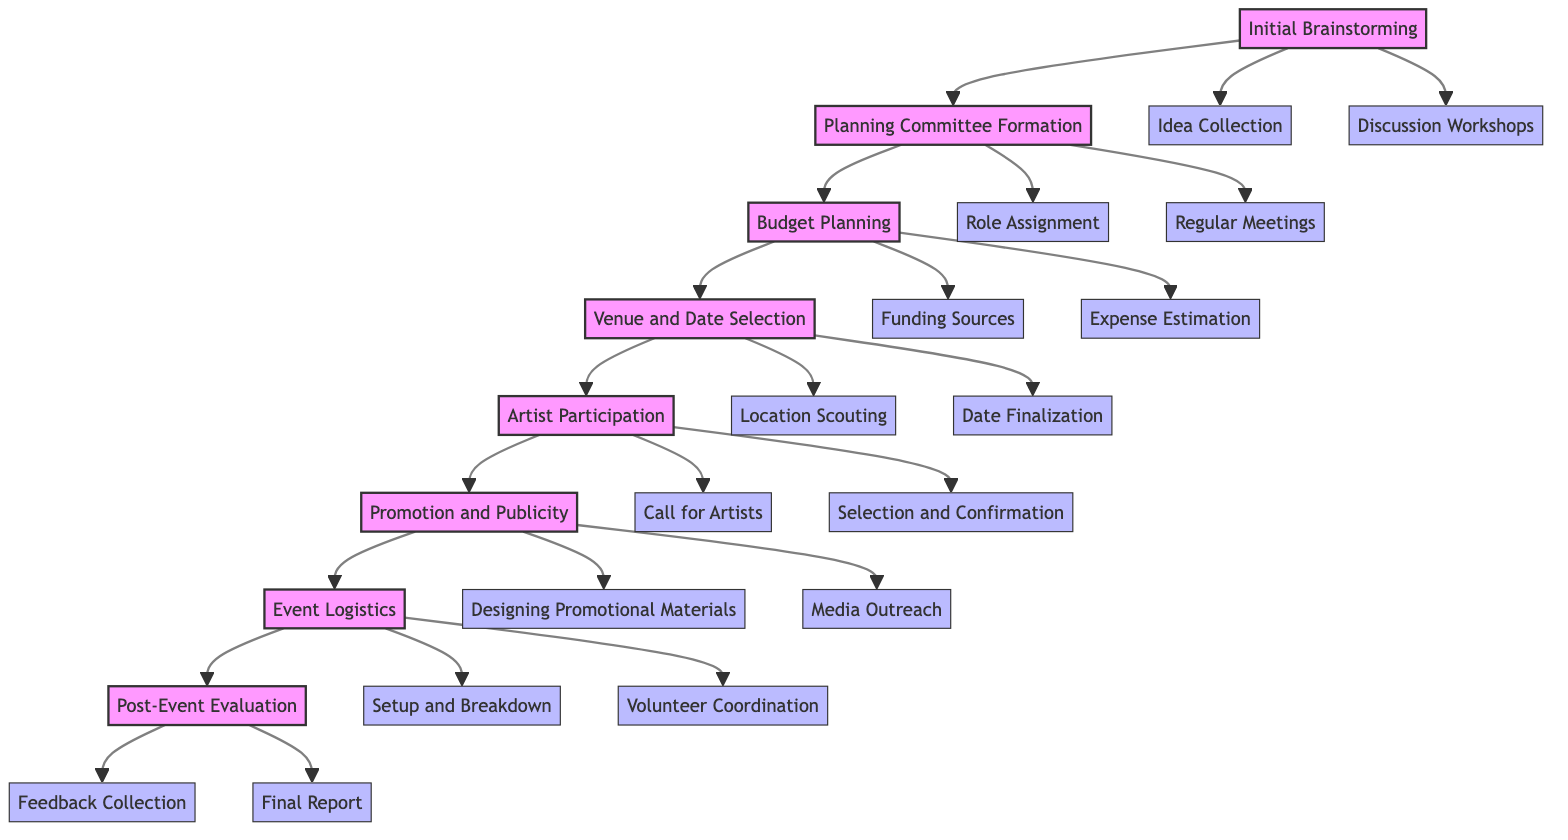What is the first stage of the festival planning? The diagram shows that the first stage of the festival planning is labeled "Initial Brainstorming." This is the starting point that connects with the subsequent step in the flow, indicated by the arrows.
Answer: Initial Brainstorming How many main stages are there in the festival planning process? By counting the main nodes in the diagram, I find there are eight distinct stages, from Initial Brainstorming to Post-Event Evaluation, indicating the overall structure of the planning process.
Answer: Eight Which stage involves gathering community input? The diagram indicates that the "Initial Brainstorming" stage includes gathering ideas from local artists and community members as one of its primary focuses. This stage aims to collect input effectively.
Answer: Initial Brainstorming What follows after Budget Planning? According to the flow of the diagram, the stage that comes directly after "Budget Planning" is "Venue and Date Selection," indicating a logical sequence in the planning steps.
Answer: Venue and Date Selection In which stage is the selection and confirmation of artists done? The "Artist Participation" stage, as indicated in the diagram, specifically includes a process labeled "Selection and Confirmation," where local artists are reviewed and confirmed for participation.
Answer: Artist Participation How are funding sources identified in the planning process? The stage of "Budget Planning" includes sub-elements for identifying funding sources. These include grants, sponsorships, and community fundraisers, which help in assessing financial resources for the festival.
Answer: Budget Planning What is the final stage of the planning process? The diagram shows that the last stage in the flowchart is "Post-Event Evaluation," which involves assessing the success of the event and areas for improvement.
Answer: Post-Event Evaluation How many sub-elements are associated with the Promotion and Publicity stage? There are two sub-elements listed under "Promotion and Publicity," which are "Designing Promotional Materials" and "Media Outreach," demonstrating the tasks involved in this stage.
Answer: Two 